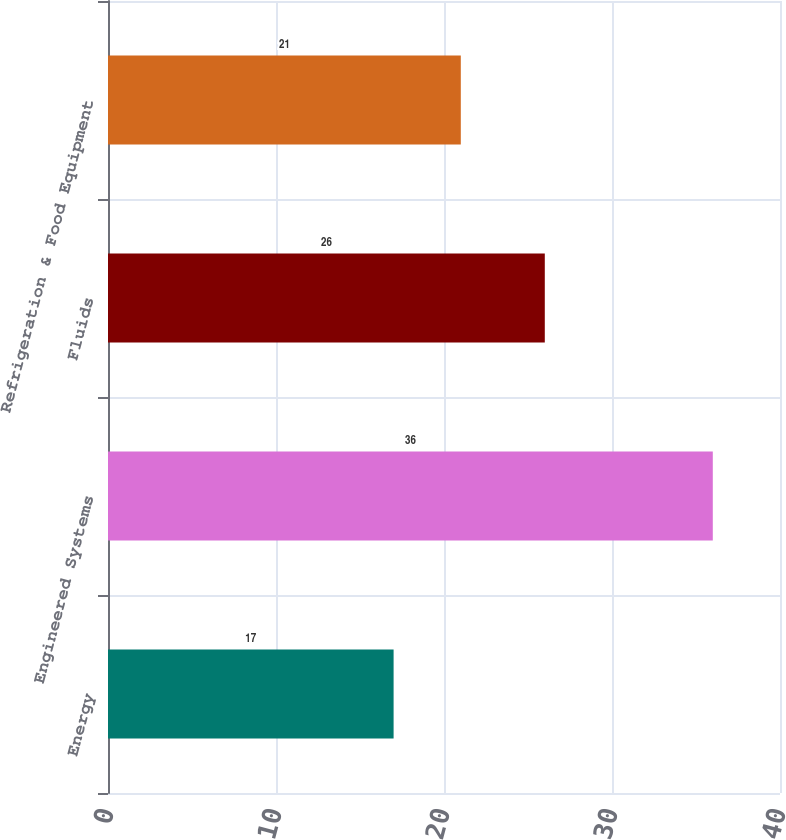Convert chart to OTSL. <chart><loc_0><loc_0><loc_500><loc_500><bar_chart><fcel>Energy<fcel>Engineered Systems<fcel>Fluids<fcel>Refrigeration & Food Equipment<nl><fcel>17<fcel>36<fcel>26<fcel>21<nl></chart> 